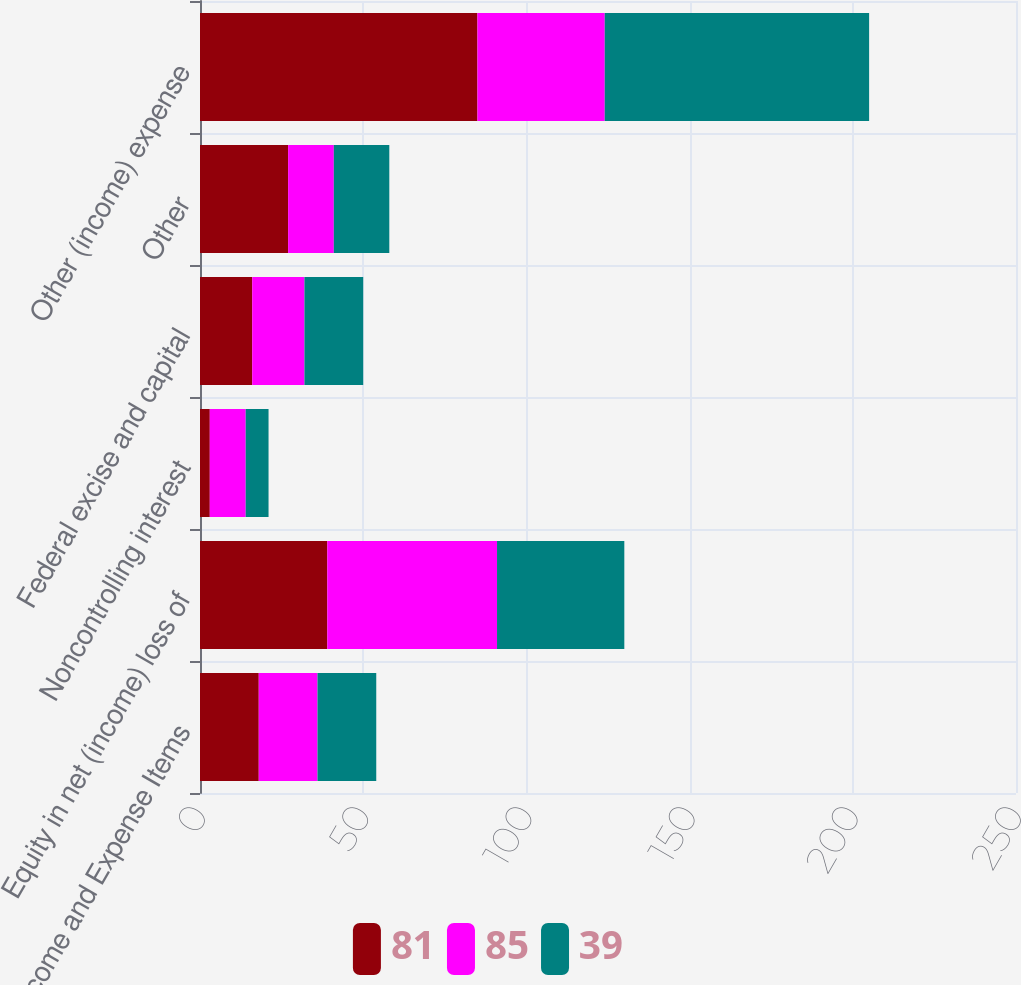Convert chart. <chart><loc_0><loc_0><loc_500><loc_500><stacked_bar_chart><ecel><fcel>Other Income and Expense Items<fcel>Equity in net (income) loss of<fcel>Noncontrolling interest<fcel>Federal excise and capital<fcel>Other<fcel>Other (income) expense<nl><fcel>81<fcel>18<fcel>39<fcel>3<fcel>16<fcel>27<fcel>85<nl><fcel>85<fcel>18<fcel>52<fcel>11<fcel>16<fcel>14<fcel>39<nl><fcel>39<fcel>18<fcel>39<fcel>7<fcel>18<fcel>17<fcel>81<nl></chart> 